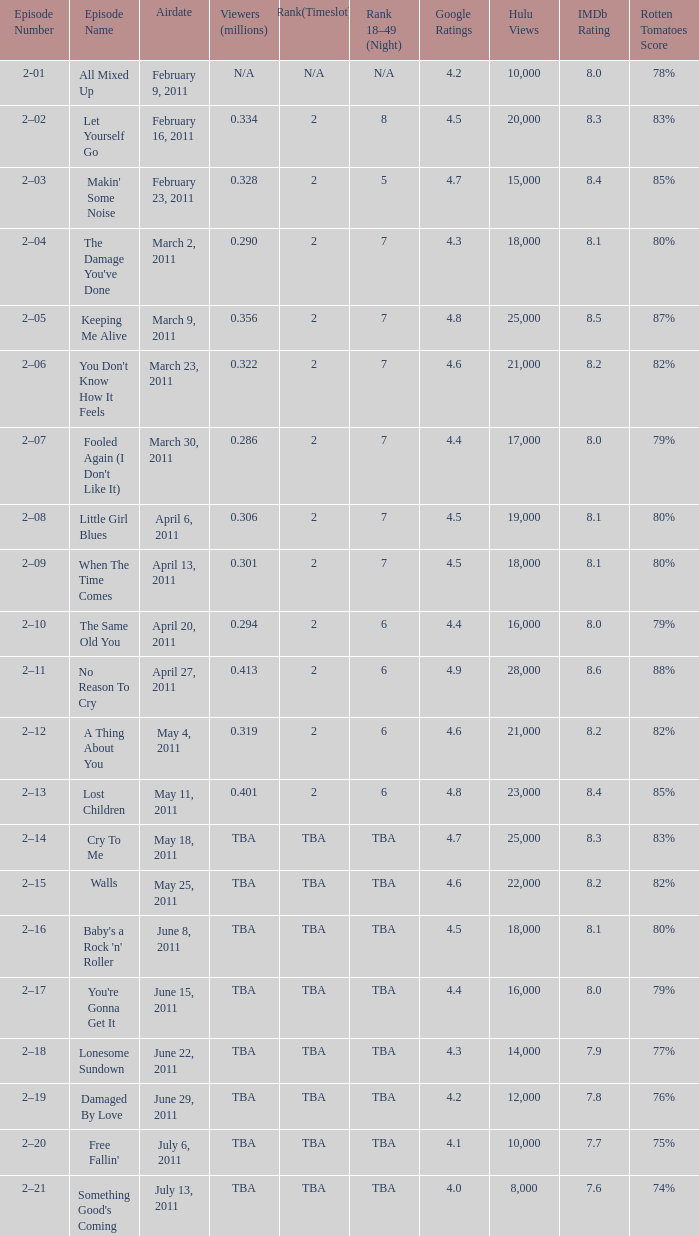What is the total rank on airdate march 30, 2011? 1.0. 